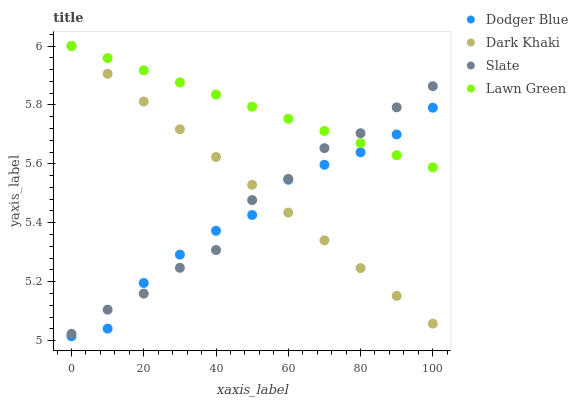Does Dodger Blue have the minimum area under the curve?
Answer yes or no. Yes. Does Lawn Green have the maximum area under the curve?
Answer yes or no. Yes. Does Slate have the minimum area under the curve?
Answer yes or no. No. Does Slate have the maximum area under the curve?
Answer yes or no. No. Is Lawn Green the smoothest?
Answer yes or no. Yes. Is Slate the roughest?
Answer yes or no. Yes. Is Slate the smoothest?
Answer yes or no. No. Is Lawn Green the roughest?
Answer yes or no. No. Does Dodger Blue have the lowest value?
Answer yes or no. Yes. Does Slate have the lowest value?
Answer yes or no. No. Does Lawn Green have the highest value?
Answer yes or no. Yes. Does Slate have the highest value?
Answer yes or no. No. Does Slate intersect Dodger Blue?
Answer yes or no. Yes. Is Slate less than Dodger Blue?
Answer yes or no. No. Is Slate greater than Dodger Blue?
Answer yes or no. No. 